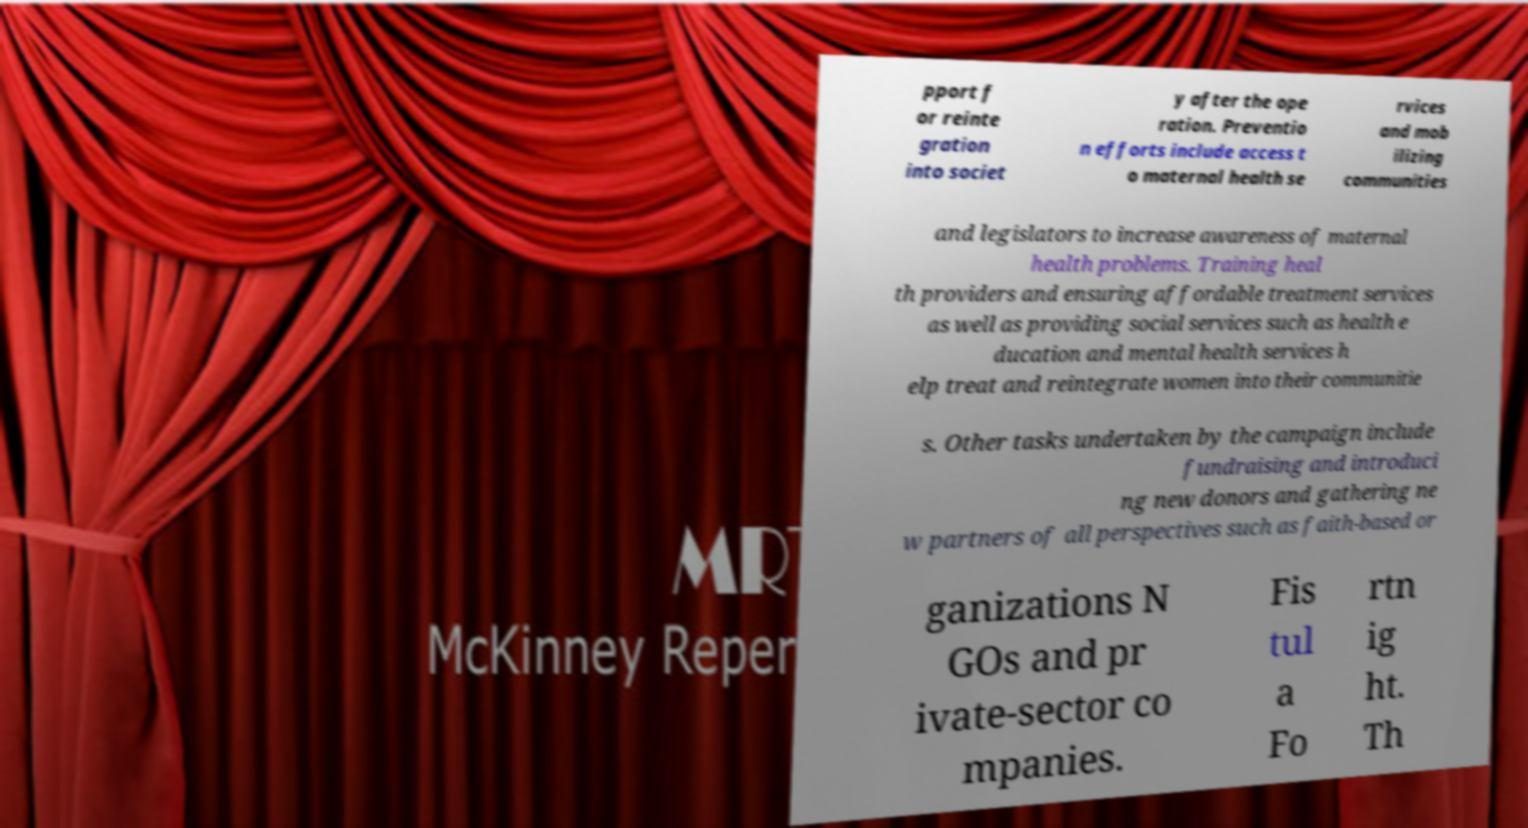There's text embedded in this image that I need extracted. Can you transcribe it verbatim? pport f or reinte gration into societ y after the ope ration. Preventio n efforts include access t o maternal health se rvices and mob ilizing communities and legislators to increase awareness of maternal health problems. Training heal th providers and ensuring affordable treatment services as well as providing social services such as health e ducation and mental health services h elp treat and reintegrate women into their communitie s. Other tasks undertaken by the campaign include fundraising and introduci ng new donors and gathering ne w partners of all perspectives such as faith-based or ganizations N GOs and pr ivate-sector co mpanies. Fis tul a Fo rtn ig ht. Th 